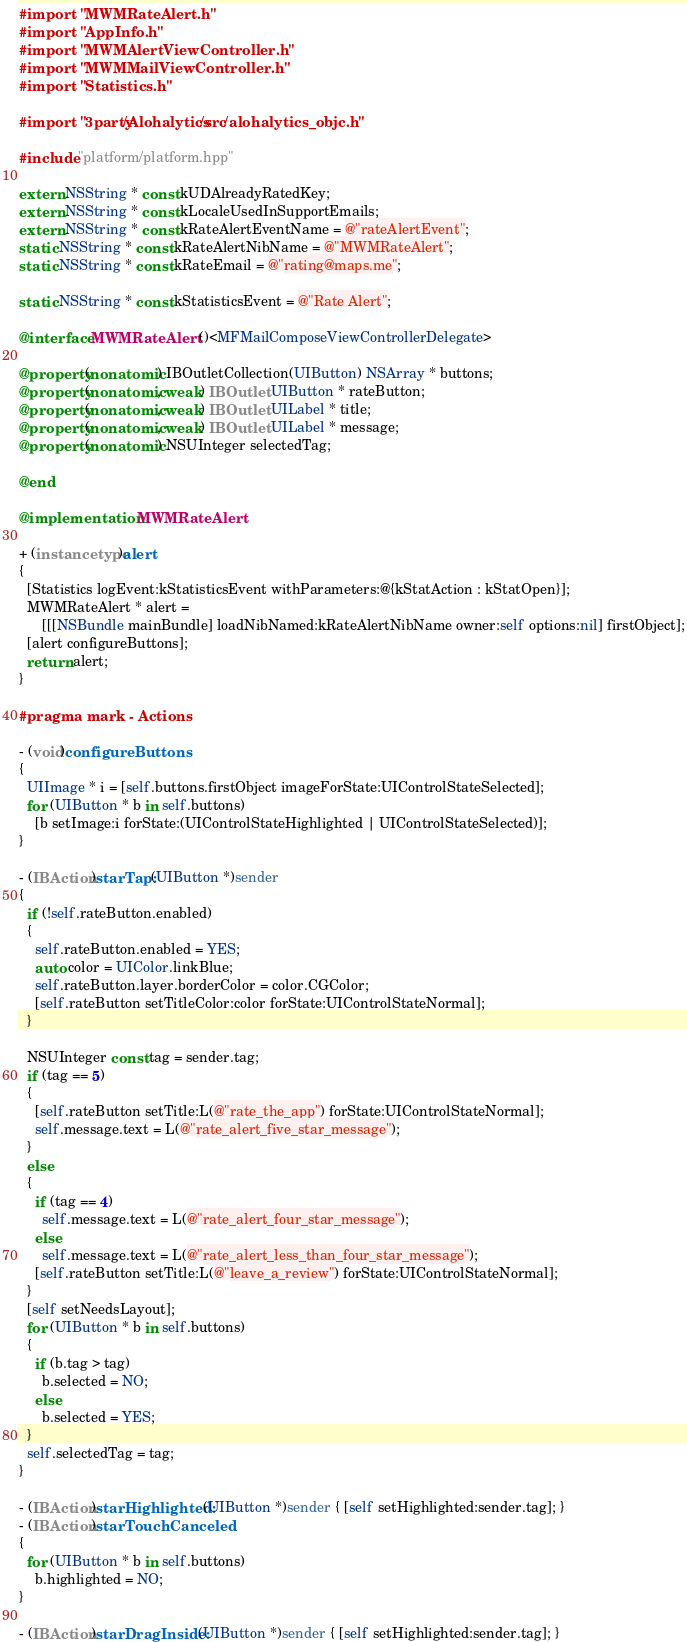Convert code to text. <code><loc_0><loc_0><loc_500><loc_500><_ObjectiveC_>#import "MWMRateAlert.h"
#import "AppInfo.h"
#import "MWMAlertViewController.h"
#import "MWMMailViewController.h"
#import "Statistics.h"

#import "3party/Alohalytics/src/alohalytics_objc.h"

#include "platform/platform.hpp"

extern NSString * const kUDAlreadyRatedKey;
extern NSString * const kLocaleUsedInSupportEmails;
extern NSString * const kRateAlertEventName = @"rateAlertEvent";
static NSString * const kRateAlertNibName = @"MWMRateAlert";
static NSString * const kRateEmail = @"rating@maps.me";

static NSString * const kStatisticsEvent = @"Rate Alert";

@interface MWMRateAlert ()<MFMailComposeViewControllerDelegate>

@property(nonatomic) IBOutletCollection(UIButton) NSArray * buttons;
@property(nonatomic, weak) IBOutlet UIButton * rateButton;
@property(nonatomic, weak) IBOutlet UILabel * title;
@property(nonatomic, weak) IBOutlet UILabel * message;
@property(nonatomic) NSUInteger selectedTag;

@end

@implementation MWMRateAlert

+ (instancetype)alert
{
  [Statistics logEvent:kStatisticsEvent withParameters:@{kStatAction : kStatOpen}];
  MWMRateAlert * alert =
      [[[NSBundle mainBundle] loadNibNamed:kRateAlertNibName owner:self options:nil] firstObject];
  [alert configureButtons];
  return alert;
}

#pragma mark - Actions

- (void)configureButtons
{
  UIImage * i = [self.buttons.firstObject imageForState:UIControlStateSelected];
  for (UIButton * b in self.buttons)
    [b setImage:i forState:(UIControlStateHighlighted | UIControlStateSelected)];
}

- (IBAction)starTap:(UIButton *)sender
{
  if (!self.rateButton.enabled)
  {
    self.rateButton.enabled = YES;
    auto color = UIColor.linkBlue;
    self.rateButton.layer.borderColor = color.CGColor;
    [self.rateButton setTitleColor:color forState:UIControlStateNormal];
  }

  NSUInteger const tag = sender.tag;
  if (tag == 5)
  {
    [self.rateButton setTitle:L(@"rate_the_app") forState:UIControlStateNormal];
    self.message.text = L(@"rate_alert_five_star_message");
  }
  else
  {
    if (tag == 4)
      self.message.text = L(@"rate_alert_four_star_message");
    else
      self.message.text = L(@"rate_alert_less_than_four_star_message");
    [self.rateButton setTitle:L(@"leave_a_review") forState:UIControlStateNormal];
  }
  [self setNeedsLayout];
  for (UIButton * b in self.buttons)
  {
    if (b.tag > tag)
      b.selected = NO;
    else
      b.selected = YES;
  }
  self.selectedTag = tag;
}

- (IBAction)starHighlighted:(UIButton *)sender { [self setHighlighted:sender.tag]; }
- (IBAction)starTouchCanceled
{
  for (UIButton * b in self.buttons)
    b.highlighted = NO;
}

- (IBAction)starDragInside:(UIButton *)sender { [self setHighlighted:sender.tag]; }</code> 